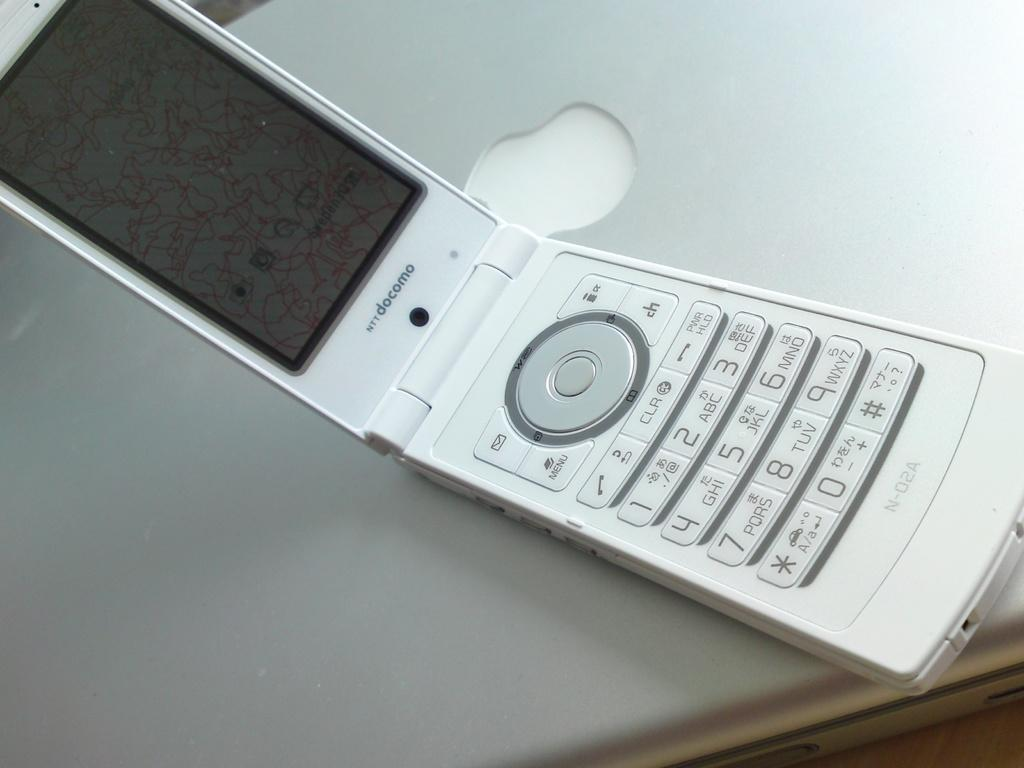What electronic device is visible in the image? There is a mobile phone in the image. What color is the mobile phone? The mobile phone is white in color. Where is the mobile phone located in the image? The mobile phone is on a laptop. What type of engine is visible in the image? There is no engine present in the image; it features a mobile phone on a laptop. How many family members can be seen in the image? There are no family members visible in the image; it only shows a mobile phone on a laptop. 